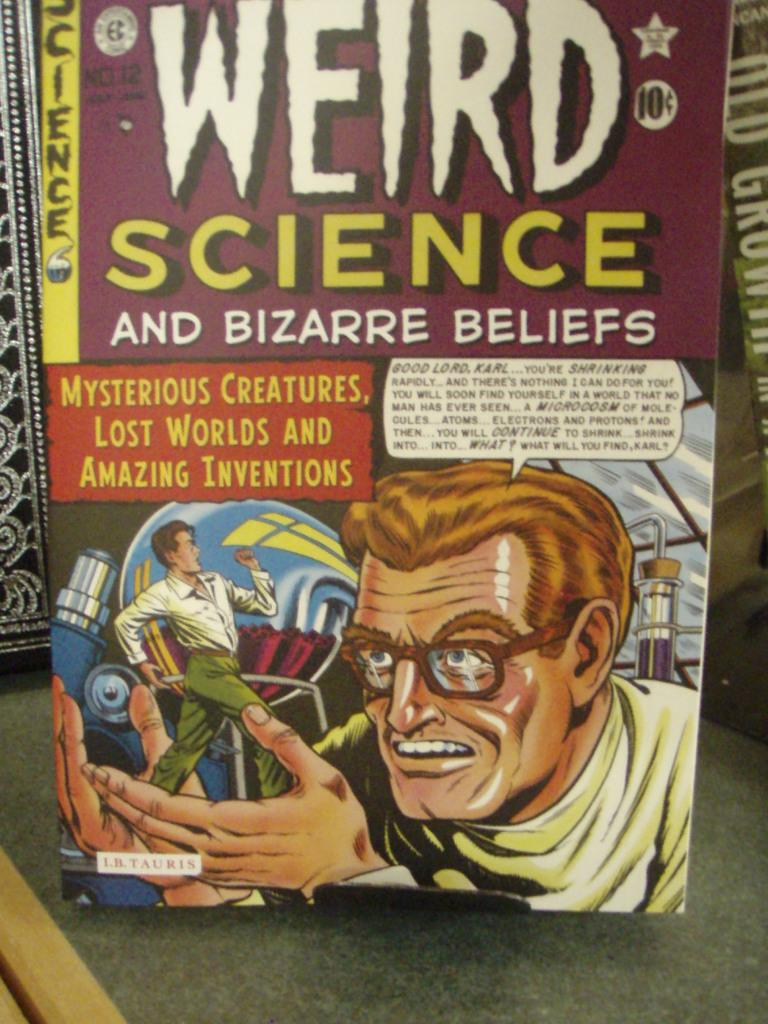<image>
Describe the image concisely. A book titled Weird Science shows a man on the cover. 